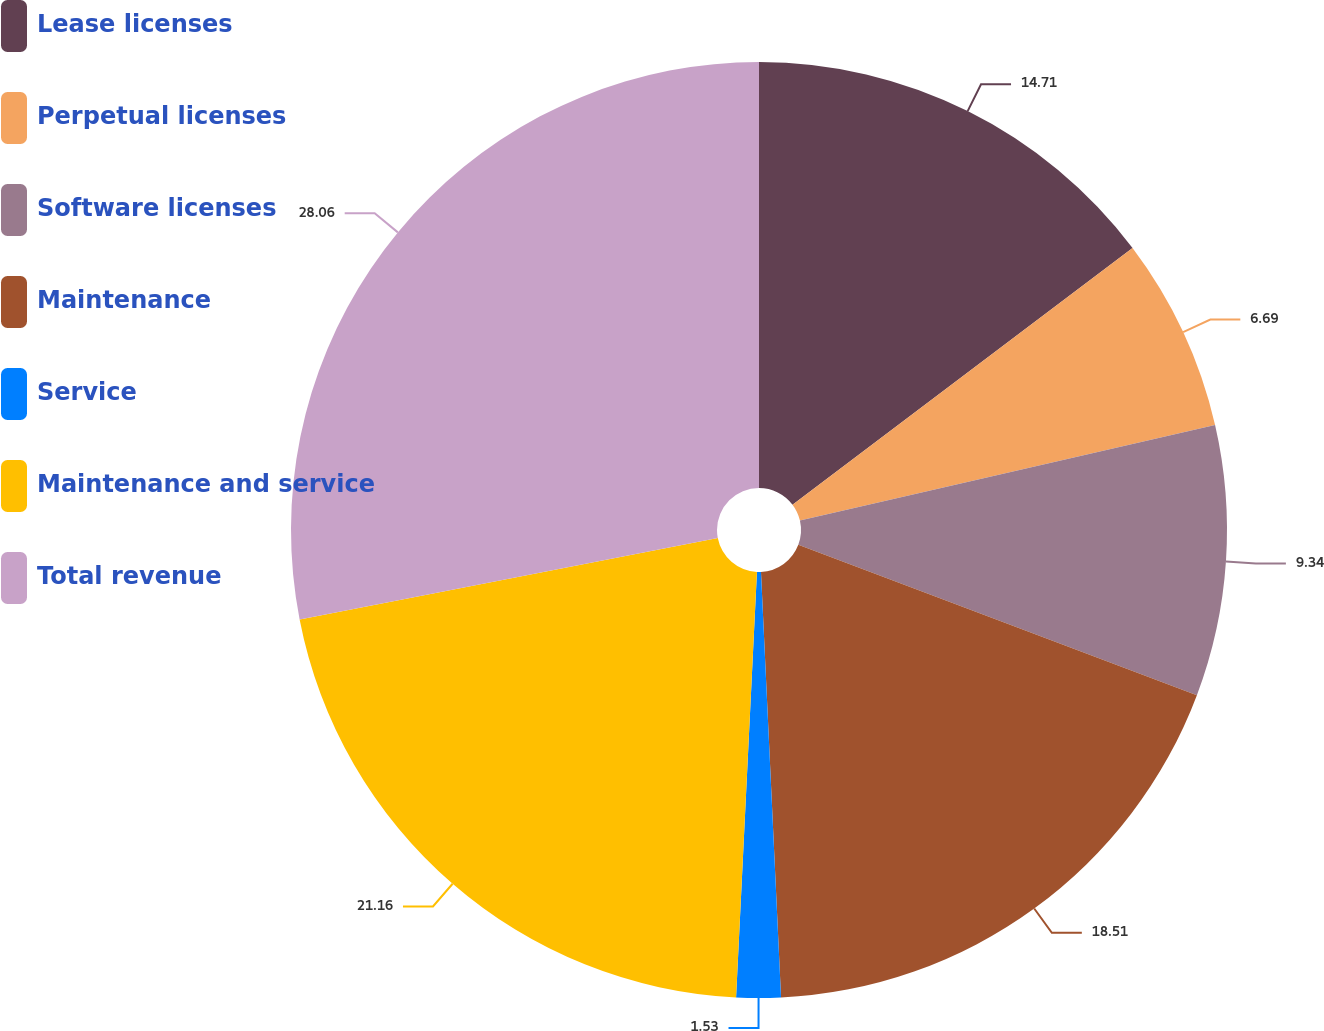Convert chart to OTSL. <chart><loc_0><loc_0><loc_500><loc_500><pie_chart><fcel>Lease licenses<fcel>Perpetual licenses<fcel>Software licenses<fcel>Maintenance<fcel>Service<fcel>Maintenance and service<fcel>Total revenue<nl><fcel>14.71%<fcel>6.69%<fcel>9.34%<fcel>18.51%<fcel>1.53%<fcel>21.16%<fcel>28.06%<nl></chart> 